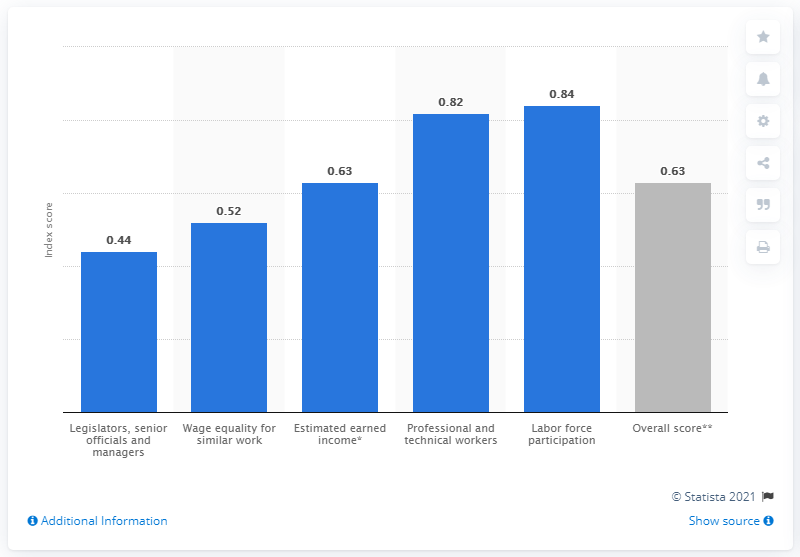How does Peru compare in gender equality for wage equality for similar work in 2021? In 2021, Peru scored 0.52 for wage equality for similar work. This score, which is relatively in the middle range, indicates that there is a noticeable gender wage gap, though it's not one of the lowest-scoring areas. This suggests that women might earn less than men for similar roles. 